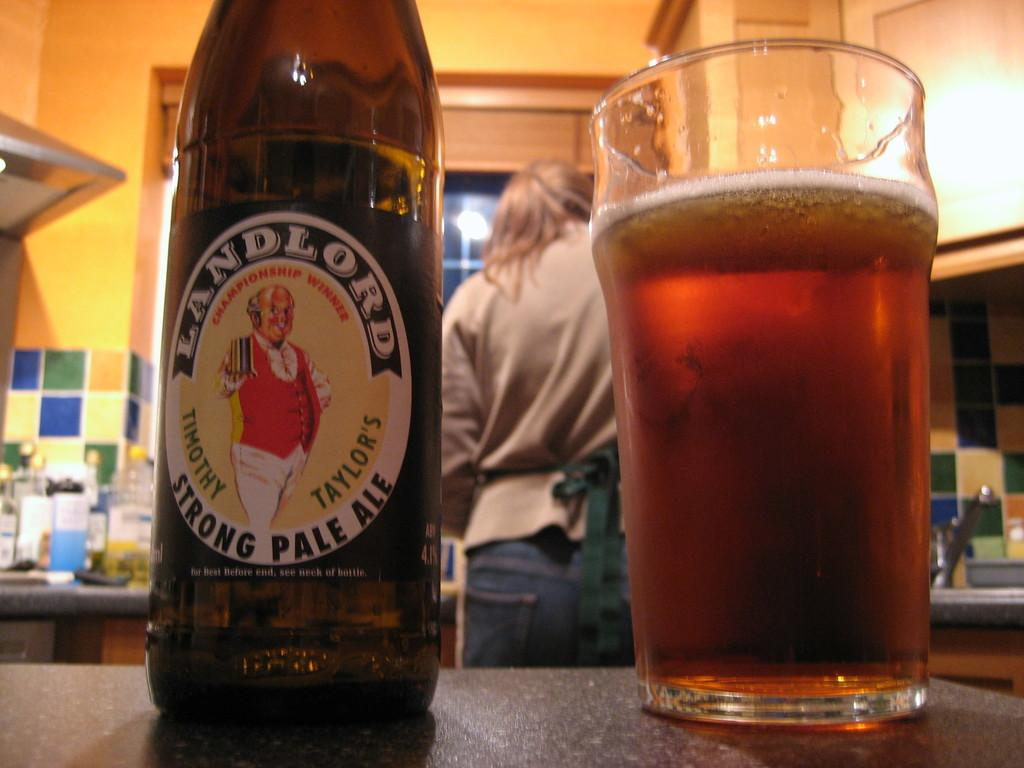<image>
Summarize the visual content of the image. A Landlord beer bottle is next to a glass of beer. 